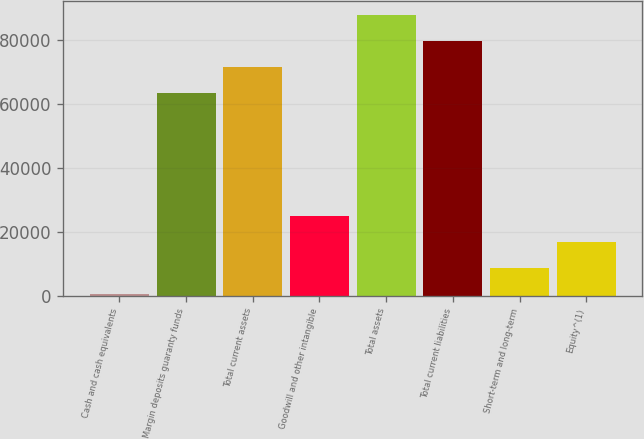<chart> <loc_0><loc_0><loc_500><loc_500><bar_chart><fcel>Cash and cash equivalents<fcel>Margin deposits guaranty funds<fcel>Total current assets<fcel>Goodwill and other intangible<fcel>Total assets<fcel>Total current liabilities<fcel>Short-term and long-term<fcel>Equity^(1)<nl><fcel>407<fcel>63309.6<fcel>71469.2<fcel>24885.8<fcel>87788.4<fcel>79628.8<fcel>8566.6<fcel>16726.2<nl></chart> 